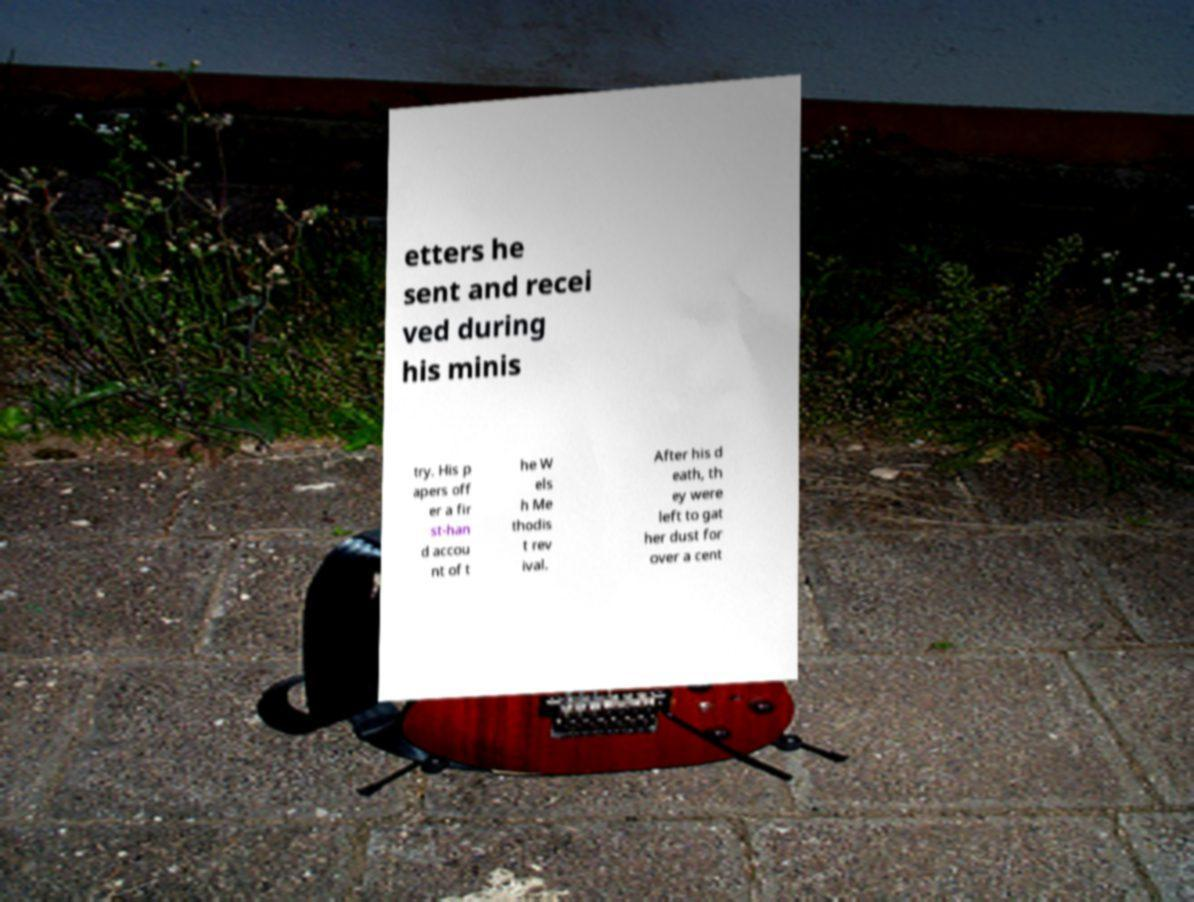Could you assist in decoding the text presented in this image and type it out clearly? etters he sent and recei ved during his minis try. His p apers off er a fir st-han d accou nt of t he W els h Me thodis t rev ival. After his d eath, th ey were left to gat her dust for over a cent 